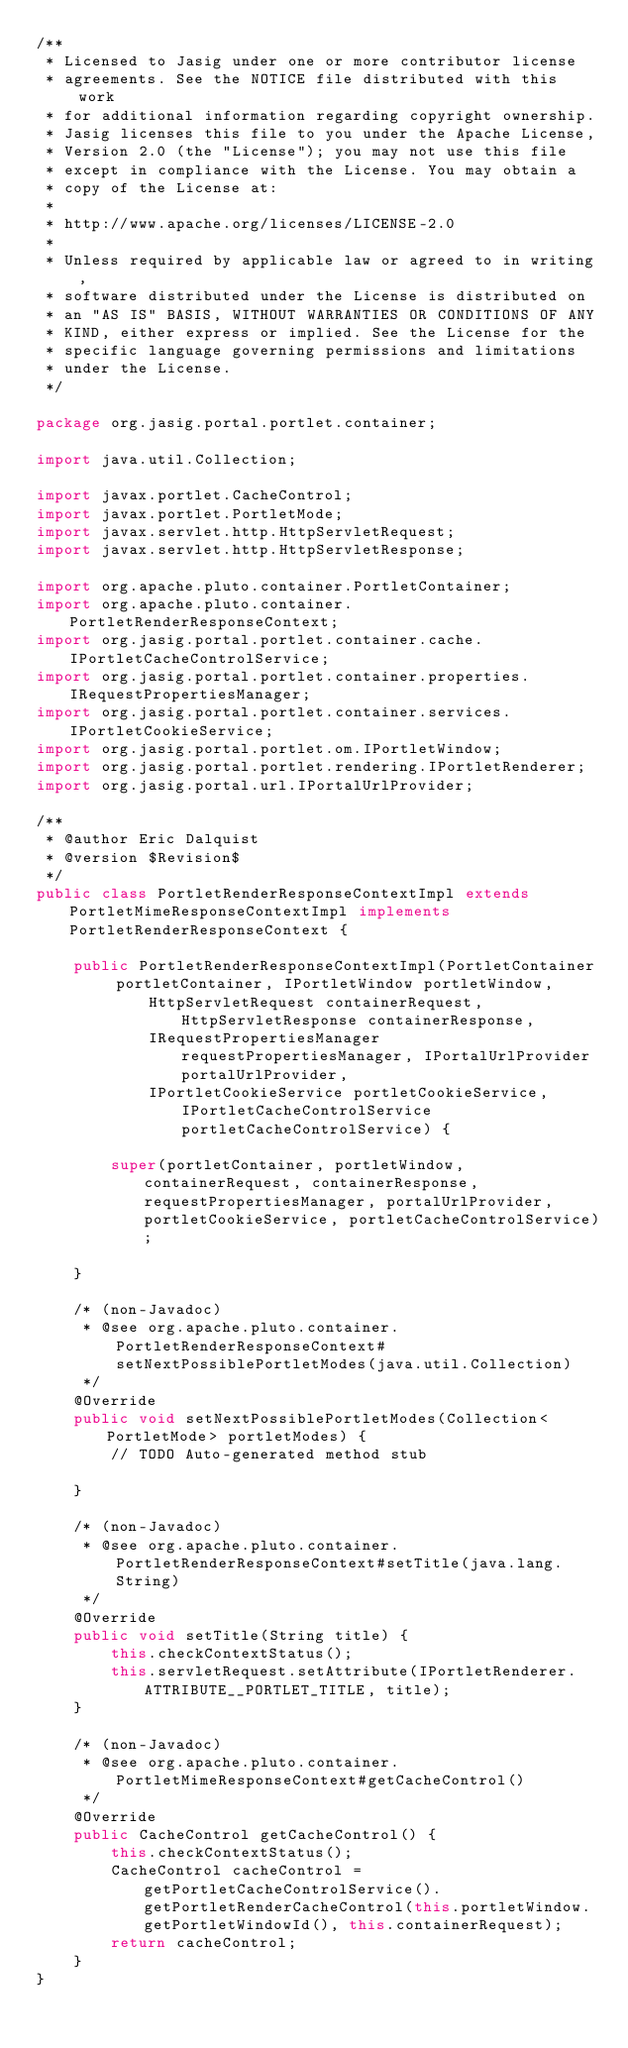<code> <loc_0><loc_0><loc_500><loc_500><_Java_>/**
 * Licensed to Jasig under one or more contributor license
 * agreements. See the NOTICE file distributed with this work
 * for additional information regarding copyright ownership.
 * Jasig licenses this file to you under the Apache License,
 * Version 2.0 (the "License"); you may not use this file
 * except in compliance with the License. You may obtain a
 * copy of the License at:
 *
 * http://www.apache.org/licenses/LICENSE-2.0
 *
 * Unless required by applicable law or agreed to in writing,
 * software distributed under the License is distributed on
 * an "AS IS" BASIS, WITHOUT WARRANTIES OR CONDITIONS OF ANY
 * KIND, either express or implied. See the License for the
 * specific language governing permissions and limitations
 * under the License.
 */

package org.jasig.portal.portlet.container;

import java.util.Collection;

import javax.portlet.CacheControl;
import javax.portlet.PortletMode;
import javax.servlet.http.HttpServletRequest;
import javax.servlet.http.HttpServletResponse;

import org.apache.pluto.container.PortletContainer;
import org.apache.pluto.container.PortletRenderResponseContext;
import org.jasig.portal.portlet.container.cache.IPortletCacheControlService;
import org.jasig.portal.portlet.container.properties.IRequestPropertiesManager;
import org.jasig.portal.portlet.container.services.IPortletCookieService;
import org.jasig.portal.portlet.om.IPortletWindow;
import org.jasig.portal.portlet.rendering.IPortletRenderer;
import org.jasig.portal.url.IPortalUrlProvider;

/**
 * @author Eric Dalquist
 * @version $Revision$
 */
public class PortletRenderResponseContextImpl extends PortletMimeResponseContextImpl implements PortletRenderResponseContext {
    
    public PortletRenderResponseContextImpl(PortletContainer portletContainer, IPortletWindow portletWindow,
            HttpServletRequest containerRequest, HttpServletResponse containerResponse,
            IRequestPropertiesManager requestPropertiesManager, IPortalUrlProvider portalUrlProvider,
            IPortletCookieService portletCookieService, IPortletCacheControlService portletCacheControlService) {

        super(portletContainer, portletWindow, containerRequest, containerResponse, requestPropertiesManager, portalUrlProvider, portletCookieService, portletCacheControlService);

    }

    /* (non-Javadoc)
     * @see org.apache.pluto.container.PortletRenderResponseContext#setNextPossiblePortletModes(java.util.Collection)
     */
    @Override
    public void setNextPossiblePortletModes(Collection<PortletMode> portletModes) {
        // TODO Auto-generated method stub

    }

    /* (non-Javadoc)
     * @see org.apache.pluto.container.PortletRenderResponseContext#setTitle(java.lang.String)
     */
    @Override
    public void setTitle(String title) {
        this.checkContextStatus();
        this.servletRequest.setAttribute(IPortletRenderer.ATTRIBUTE__PORTLET_TITLE, title);
    }

    /* (non-Javadoc)
     * @see org.apache.pluto.container.PortletMimeResponseContext#getCacheControl()
     */
    @Override
    public CacheControl getCacheControl() {
        this.checkContextStatus();
        CacheControl cacheControl = getPortletCacheControlService().getPortletRenderCacheControl(this.portletWindow.getPortletWindowId(), this.containerRequest);    
        return cacheControl;
    }
}
</code> 